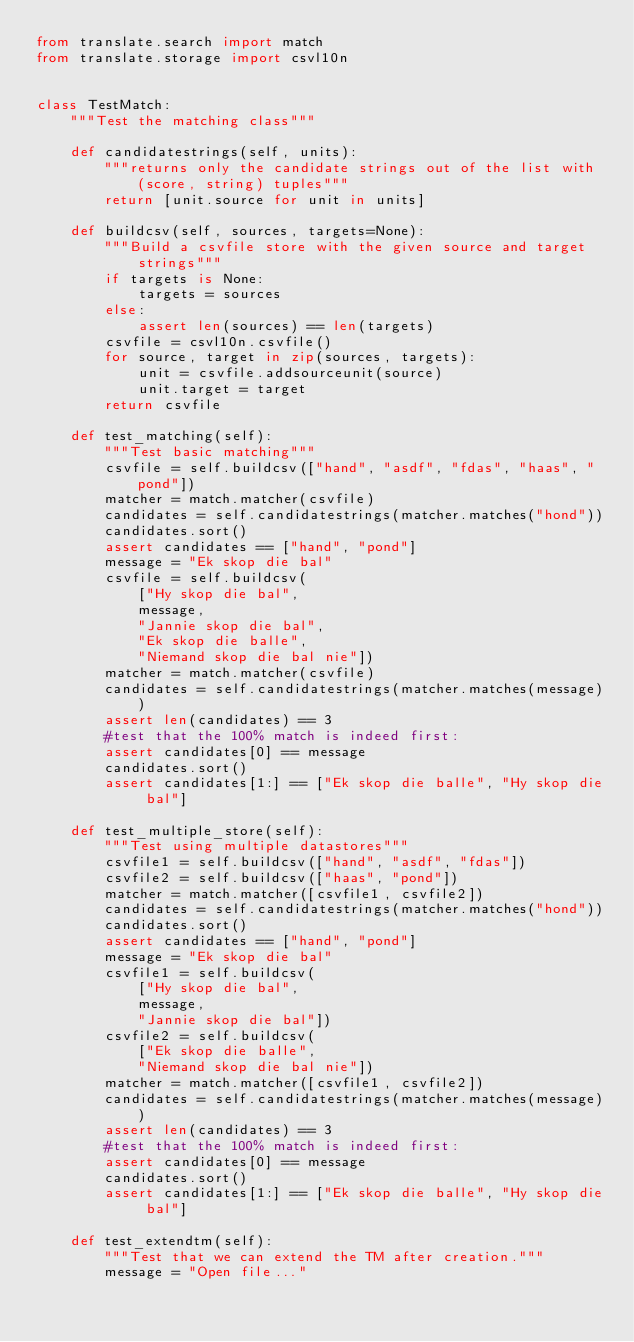Convert code to text. <code><loc_0><loc_0><loc_500><loc_500><_Python_>from translate.search import match
from translate.storage import csvl10n


class TestMatch:
    """Test the matching class"""

    def candidatestrings(self, units):
        """returns only the candidate strings out of the list with (score, string) tuples"""
        return [unit.source for unit in units]

    def buildcsv(self, sources, targets=None):
        """Build a csvfile store with the given source and target strings"""
        if targets is None:
            targets = sources
        else:
            assert len(sources) == len(targets)
        csvfile = csvl10n.csvfile()
        for source, target in zip(sources, targets):
            unit = csvfile.addsourceunit(source)
            unit.target = target
        return csvfile

    def test_matching(self):
        """Test basic matching"""
        csvfile = self.buildcsv(["hand", "asdf", "fdas", "haas", "pond"])
        matcher = match.matcher(csvfile)
        candidates = self.candidatestrings(matcher.matches("hond"))
        candidates.sort()
        assert candidates == ["hand", "pond"]
        message = "Ek skop die bal"
        csvfile = self.buildcsv(
            ["Hy skop die bal",
            message,
            "Jannie skop die bal",
            "Ek skop die balle",
            "Niemand skop die bal nie"])
        matcher = match.matcher(csvfile)
        candidates = self.candidatestrings(matcher.matches(message))
        assert len(candidates) == 3
        #test that the 100% match is indeed first:
        assert candidates[0] == message
        candidates.sort()
        assert candidates[1:] == ["Ek skop die balle", "Hy skop die bal"]

    def test_multiple_store(self):
        """Test using multiple datastores"""
        csvfile1 = self.buildcsv(["hand", "asdf", "fdas"])
        csvfile2 = self.buildcsv(["haas", "pond"])
        matcher = match.matcher([csvfile1, csvfile2])
        candidates = self.candidatestrings(matcher.matches("hond"))
        candidates.sort()
        assert candidates == ["hand", "pond"]
        message = "Ek skop die bal"
        csvfile1 = self.buildcsv(
            ["Hy skop die bal",
            message,
            "Jannie skop die bal"])
        csvfile2 = self.buildcsv(
            ["Ek skop die balle",
            "Niemand skop die bal nie"])
        matcher = match.matcher([csvfile1, csvfile2])
        candidates = self.candidatestrings(matcher.matches(message))
        assert len(candidates) == 3
        #test that the 100% match is indeed first:
        assert candidates[0] == message
        candidates.sort()
        assert candidates[1:] == ["Ek skop die balle", "Hy skop die bal"]

    def test_extendtm(self):
        """Test that we can extend the TM after creation."""
        message = "Open file..."</code> 